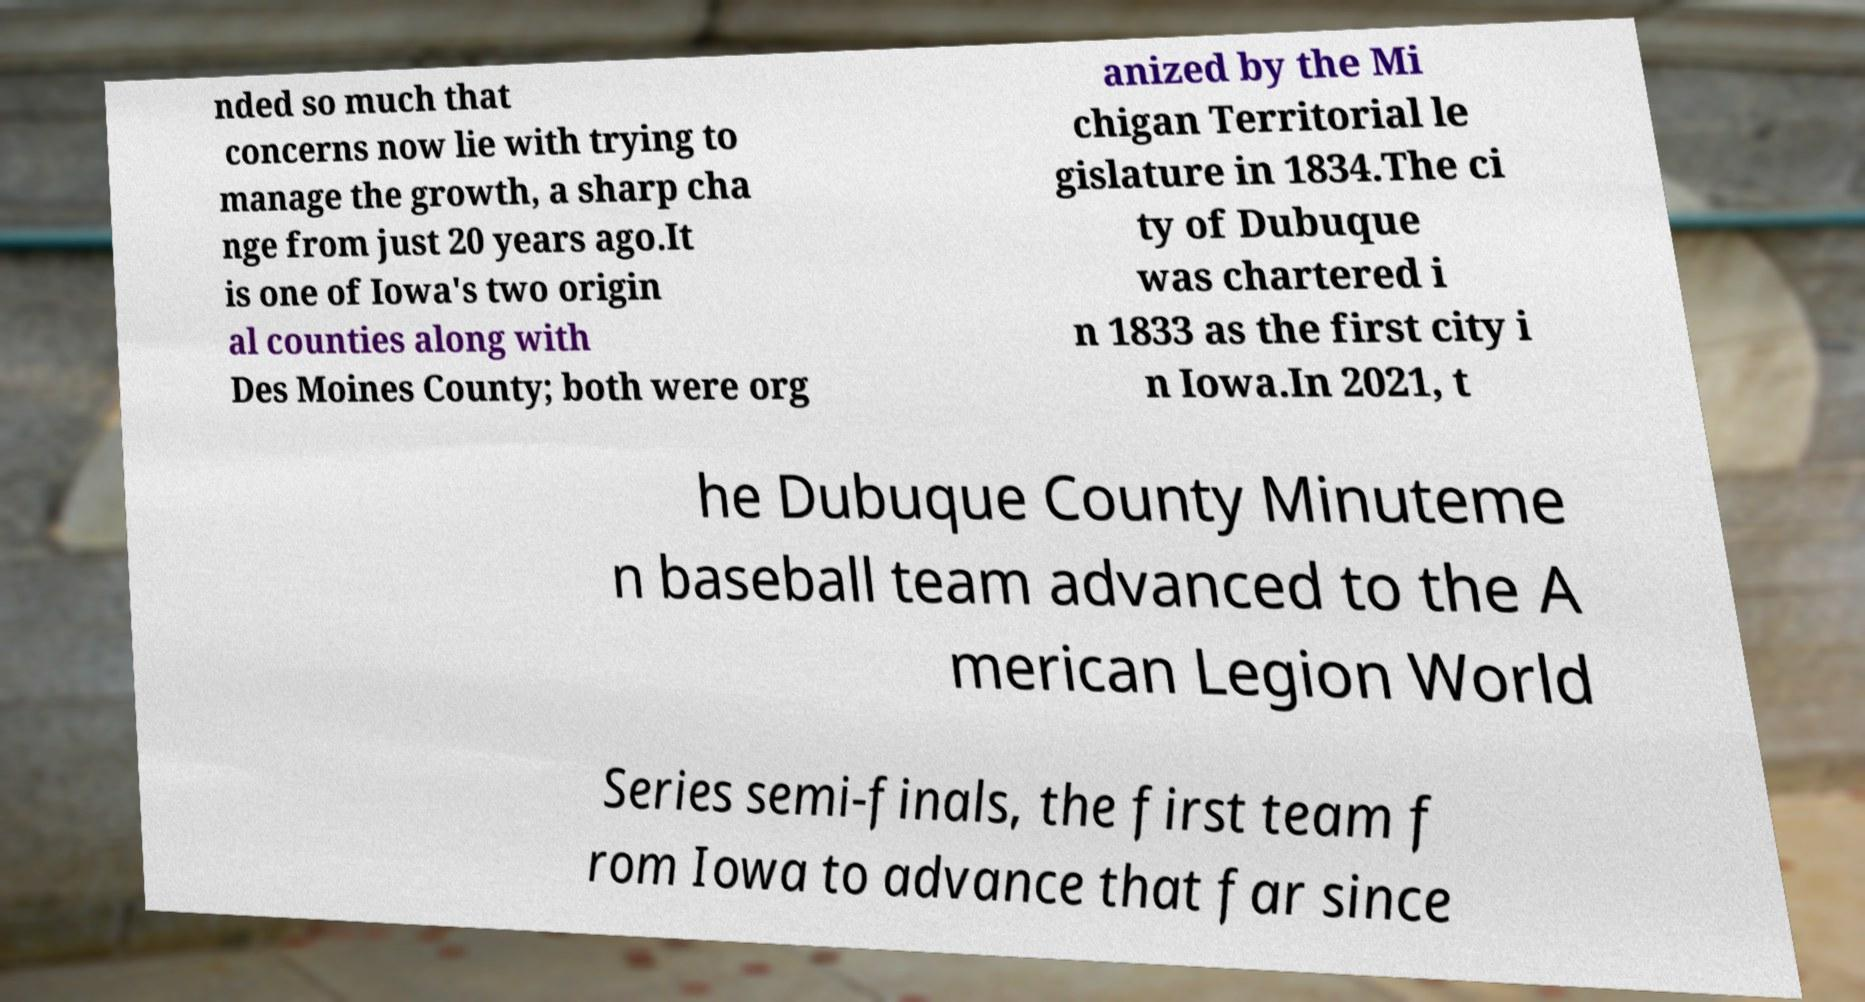Could you assist in decoding the text presented in this image and type it out clearly? nded so much that concerns now lie with trying to manage the growth, a sharp cha nge from just 20 years ago.It is one of Iowa's two origin al counties along with Des Moines County; both were org anized by the Mi chigan Territorial le gislature in 1834.The ci ty of Dubuque was chartered i n 1833 as the first city i n Iowa.In 2021, t he Dubuque County Minuteme n baseball team advanced to the A merican Legion World Series semi-finals, the first team f rom Iowa to advance that far since 